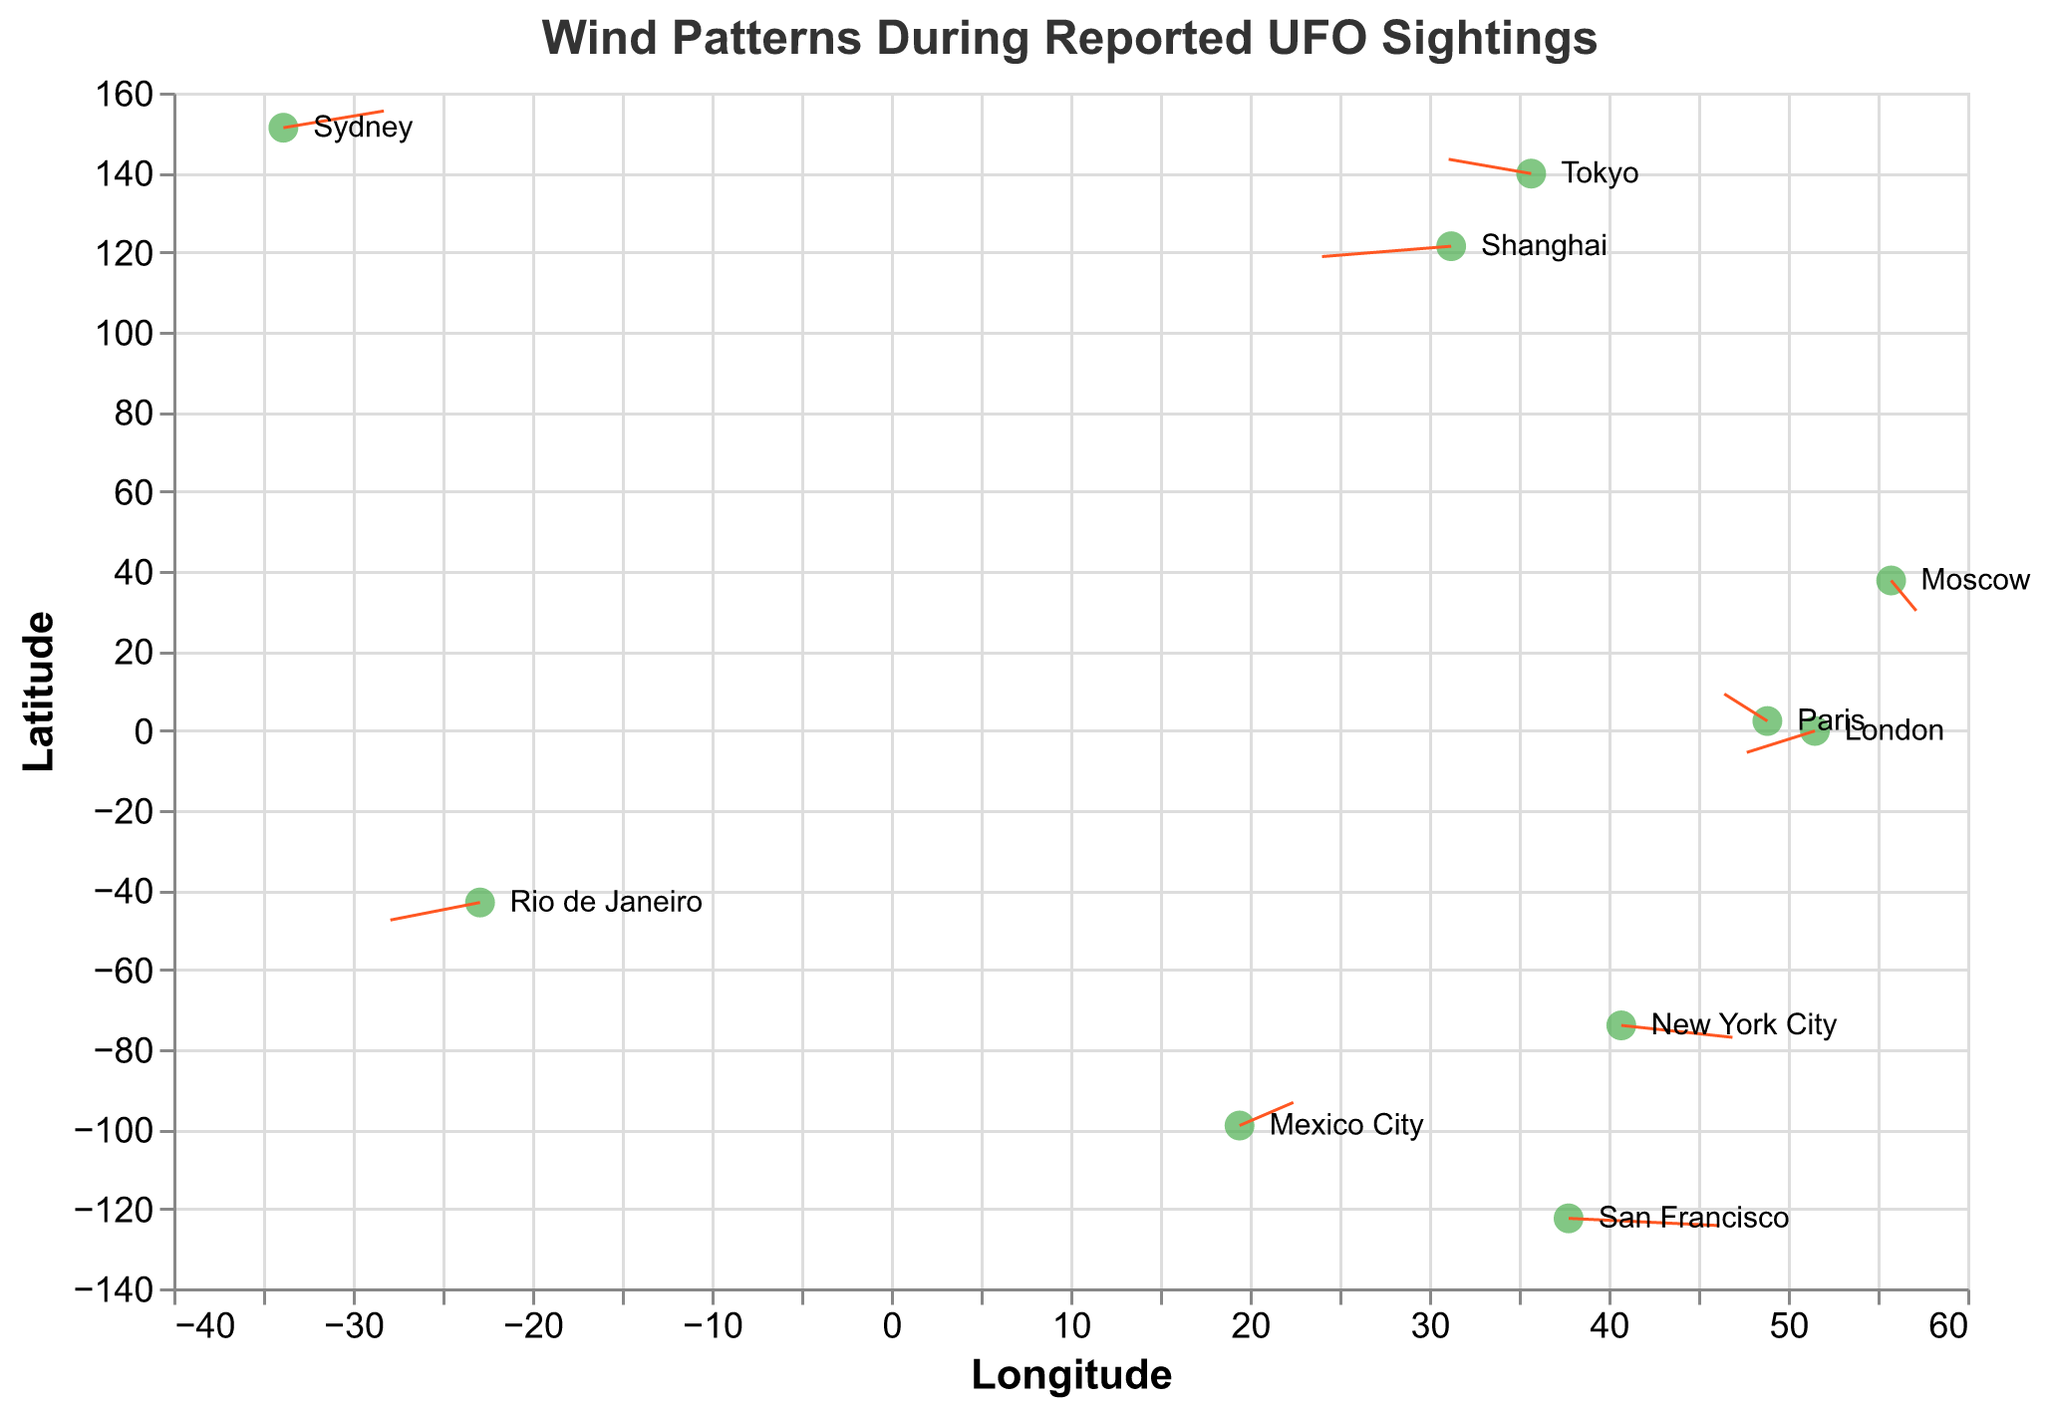Which region had a UFO sighting on November 17, 2022? The tooltip data in the figure shows the "sighting_date" for each point. Finding the matching date will reveal the region.
Answer: Paris How many regions have reported UFO sightings in 2023? By checking the "sighting_date" in the tooltip for each point and counting those dated in 2023, we find there are three such sightings.
Answer: 3 Which region experienced the strongest wind speed in the U direction, and what was the value? The U-vector indicates the wind’s horizontal component. Among the data points, San Francisco has the highest U value of 4.2.
Answer: San Francisco, 4.2 Compare the wind directions in New York City and Tokyo. Are they generally moving in similar or opposite directions? New York City has U = 3.1 and V = -1.5 (mostly eastward and slightly southward). Tokyo has U = -2.3 and V = 1.8 (west and north). These vectors are generally in opposite directions in terms of their U components.
Answer: Opposite directions Which sighting took place in the Southern Hemisphere? From the latitude values, sightings in the Southern Hemisphere have negative y values. Both Sydney and Rio de Janeiro meet this criterion.
Answer: Sydney and Rio de Janeiro What's the average wind direction in the V direction for sightings in Paris and London? V values for Paris and London are 3.4 and -2.7, respectively. Average = (3.4 + (-2.7)) / 2 = 0.35
Answer: 0.35 Identify the sighting where the wind is moving predominantly eastward. Which region is it? Look for the highest positive U value, which indicates movement to the east. San Francisco has U = 4.2, the highest eastward component.
Answer: San Francisco Compare the wind intensity (magnitude) between Tokyo and Moscow. Which region experienced stronger wind? Wind intensity is calculated using the formula √(u^2 + v^2). For Tokyo: √((-2.3)^2 + (1.8)^2) ≈ 2.94, and for Moscow: √((0.7)^2 + (-3.8)^2) ≈ 3.86. Moscow has stronger wind intensity.
Answer: Moscow Which region experienced winds predominantly moving southward, and what was the V value? Winds moving southward have negative V values. The lowest V is in Moscow with -3.8.
Answer: Moscow, -3.8 From the information given, is there a noticeable pattern in wind direction during UFO sightings? Analyzing the U and V vectors across regions reveals that wind patterns vary significantly with no common directional trend observed during UFO sightings.
Answer: No noticeable pattern 